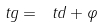Convert formula to latex. <formula><loc_0><loc_0><loc_500><loc_500>\ t g = \ t d + \varphi</formula> 